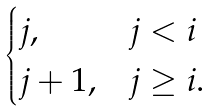Convert formula to latex. <formula><loc_0><loc_0><loc_500><loc_500>\begin{cases} j , & j < i \\ j + 1 , & j \geq i . \end{cases}</formula> 